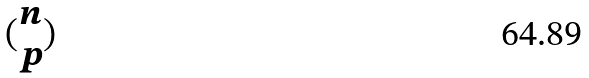<formula> <loc_0><loc_0><loc_500><loc_500>( \begin{matrix} n \\ p \end{matrix} )</formula> 